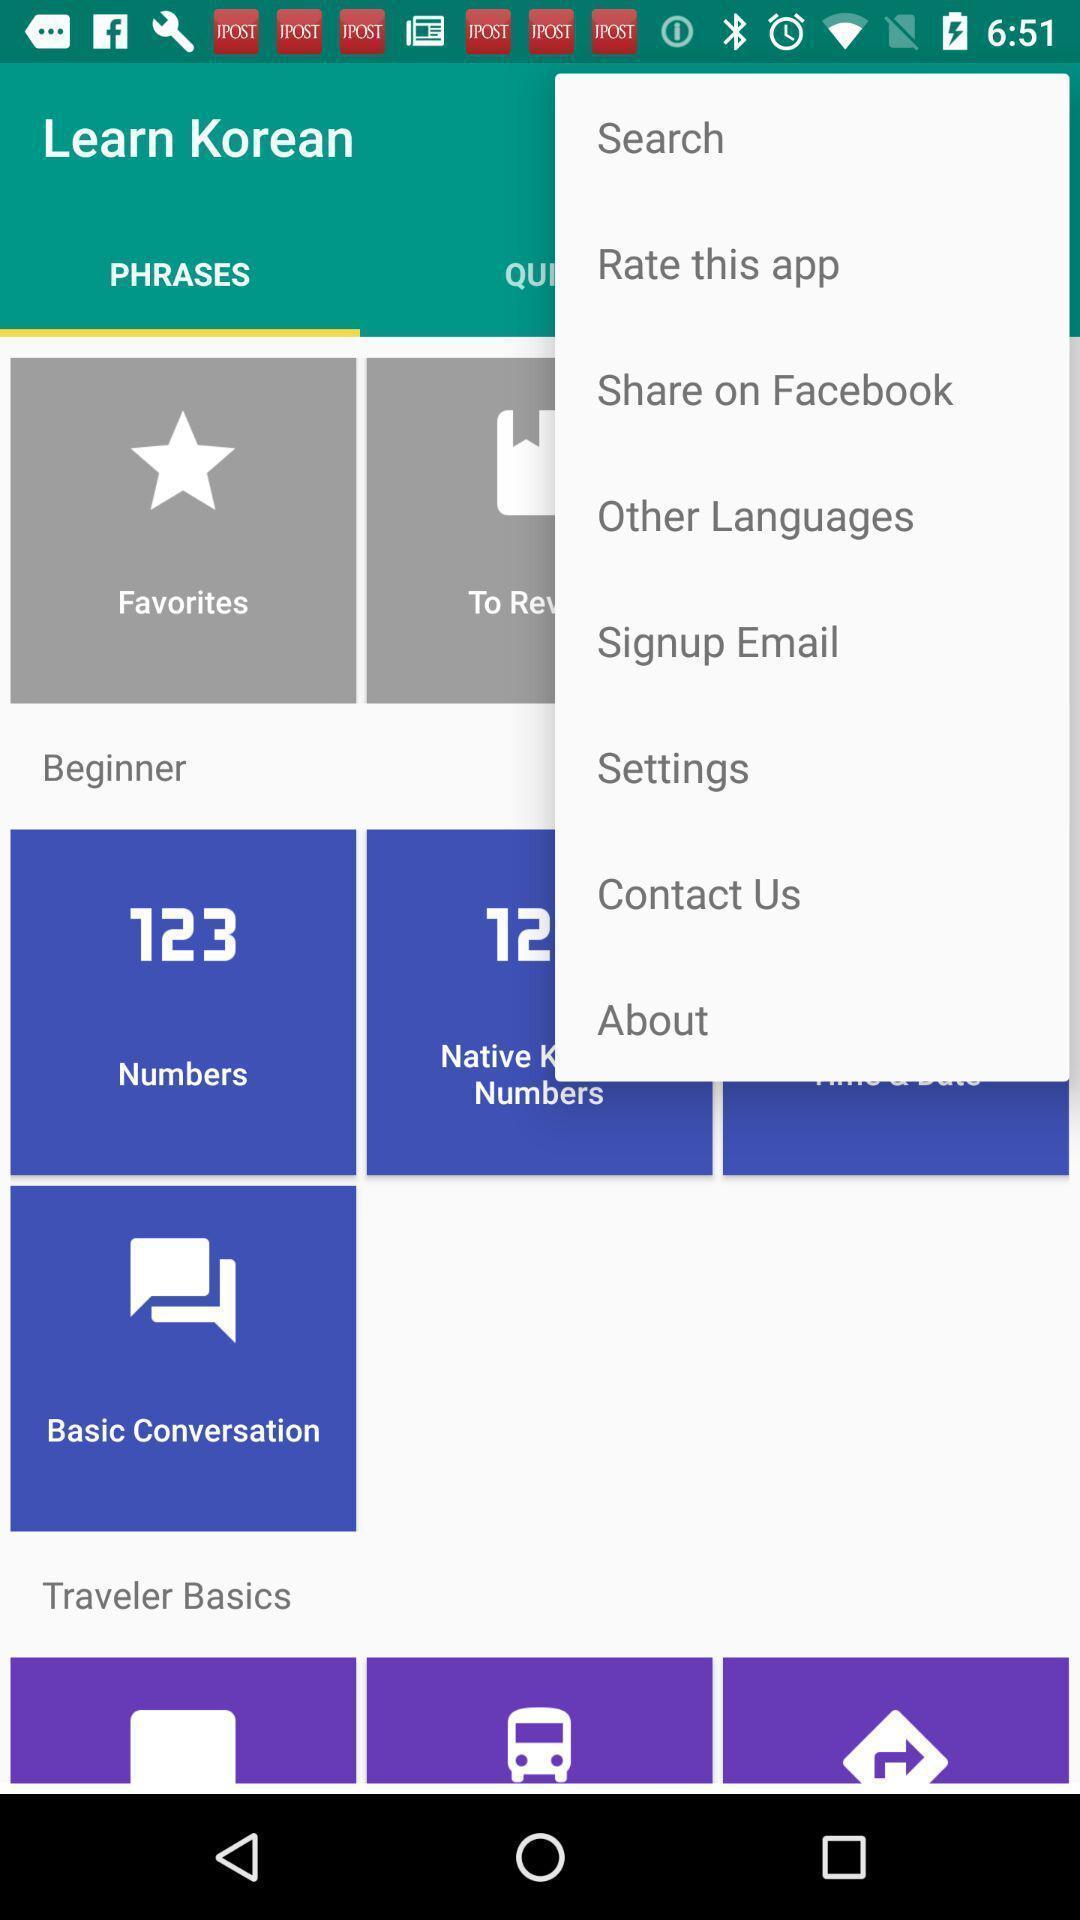Describe the visual elements of this screenshot. Screen displaying to learn a language. 